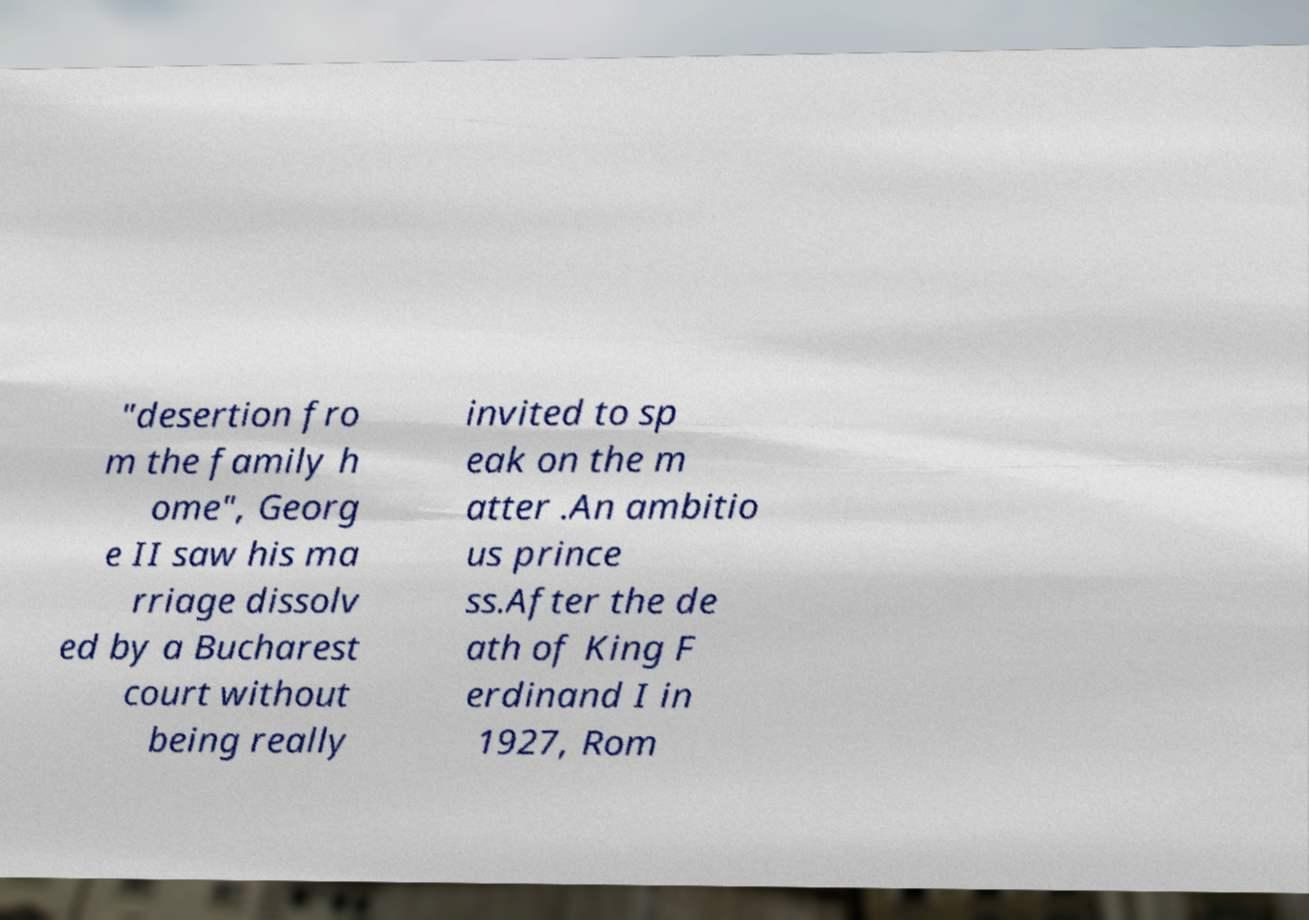I need the written content from this picture converted into text. Can you do that? "desertion fro m the family h ome", Georg e II saw his ma rriage dissolv ed by a Bucharest court without being really invited to sp eak on the m atter .An ambitio us prince ss.After the de ath of King F erdinand I in 1927, Rom 